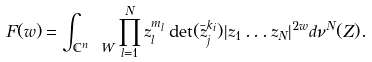Convert formula to latex. <formula><loc_0><loc_0><loc_500><loc_500>F ( w ) = \int _ { \mathbb { C } ^ { n } \ W } \prod _ { l = 1 } ^ { N } z _ { l } ^ { m _ { l } } \det ( \bar { z } _ { j } ^ { k _ { i } } ) | z _ { 1 } \dots z _ { N } | ^ { 2 w } d \nu ^ { N } ( Z ) .</formula> 